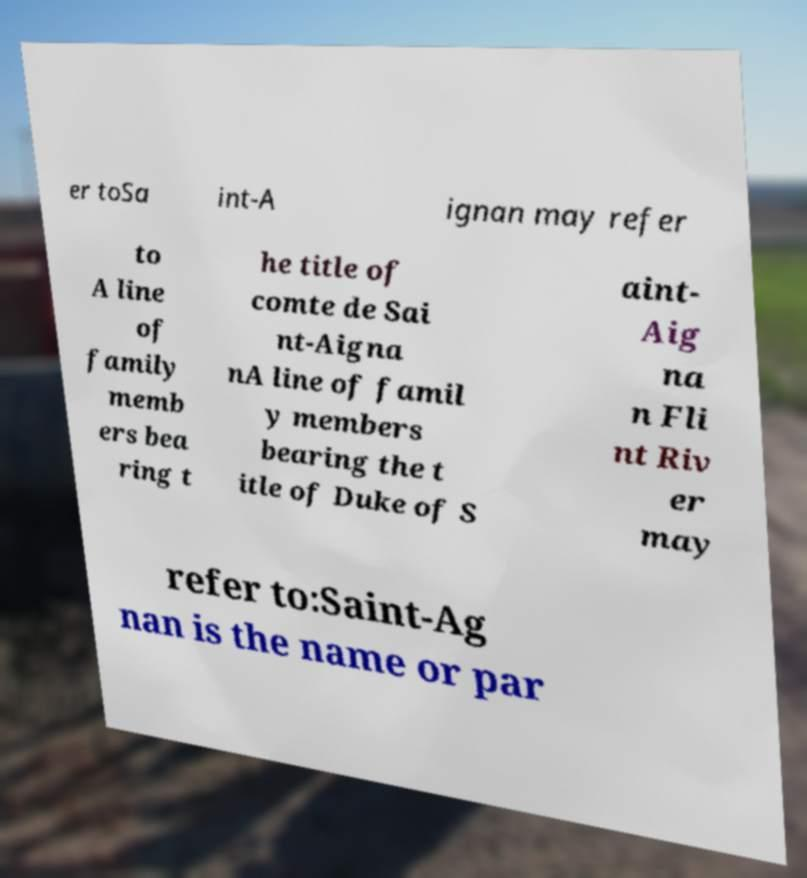Could you assist in decoding the text presented in this image and type it out clearly? er toSa int-A ignan may refer to A line of family memb ers bea ring t he title of comte de Sai nt-Aigna nA line of famil y members bearing the t itle of Duke of S aint- Aig na n Fli nt Riv er may refer to:Saint-Ag nan is the name or par 